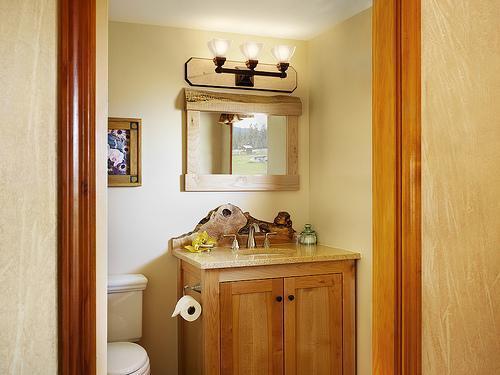How many toilet paper rolls are visible?
Give a very brief answer. 1. 